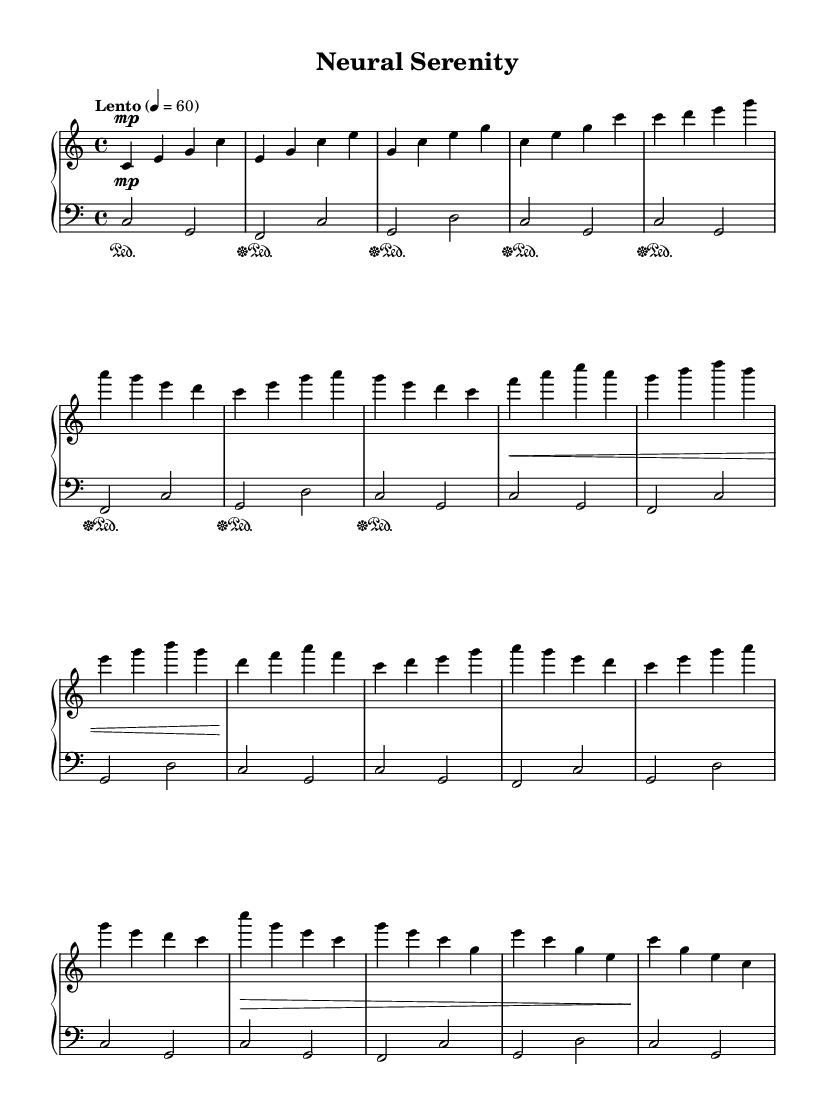What is the key signature of this music? The key signature is C major, which has no sharps or flats.
Answer: C major What is the time signature of this music? The time signature is indicated as 4/4, meaning there are four beats per measure.
Answer: 4/4 What is the tempo marking for this piece? The tempo marking is "Lento," which indicates a slow pace of the music.
Answer: Lento How many times is the bass pattern repeated in this composition? The bass pattern is repeated five times throughout the composition, as indicated by "repeat unfold 5."
Answer: 5 What is the dynamic marking used in the introduction? The dynamic marking in the introduction is marked as "mp," which stands for mezzo-piano, indicating a moderately soft volume.
Answer: mp Which section of the piece is labeled as "B"? Section "B" consists of the measures with the notes f a c a, g b d b, e g b g, and d f a f, which differentiates it from section A.
Answer: B Does the right hand or left hand play the melody in this piece? The right hand plays the melody, while the left hand provides the harmonic support in the bass.
Answer: Right hand 